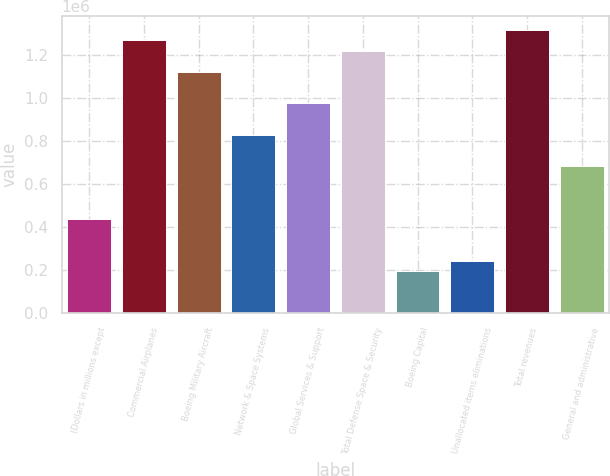<chart> <loc_0><loc_0><loc_500><loc_500><bar_chart><fcel>(Dollars in millions except<fcel>Commercial Airplanes<fcel>Boeing Military Aircraft<fcel>Network & Space Systems<fcel>Global Services & Support<fcel>Total Defense Space & Security<fcel>Boeing Capital<fcel>Unallocated items eliminations<fcel>Total revenues<fcel>General and administrative<nl><fcel>438383<fcel>1.26643e+06<fcel>1.12031e+06<fcel>828054<fcel>974181<fcel>1.21773e+06<fcel>194839<fcel>243548<fcel>1.31514e+06<fcel>681928<nl></chart> 